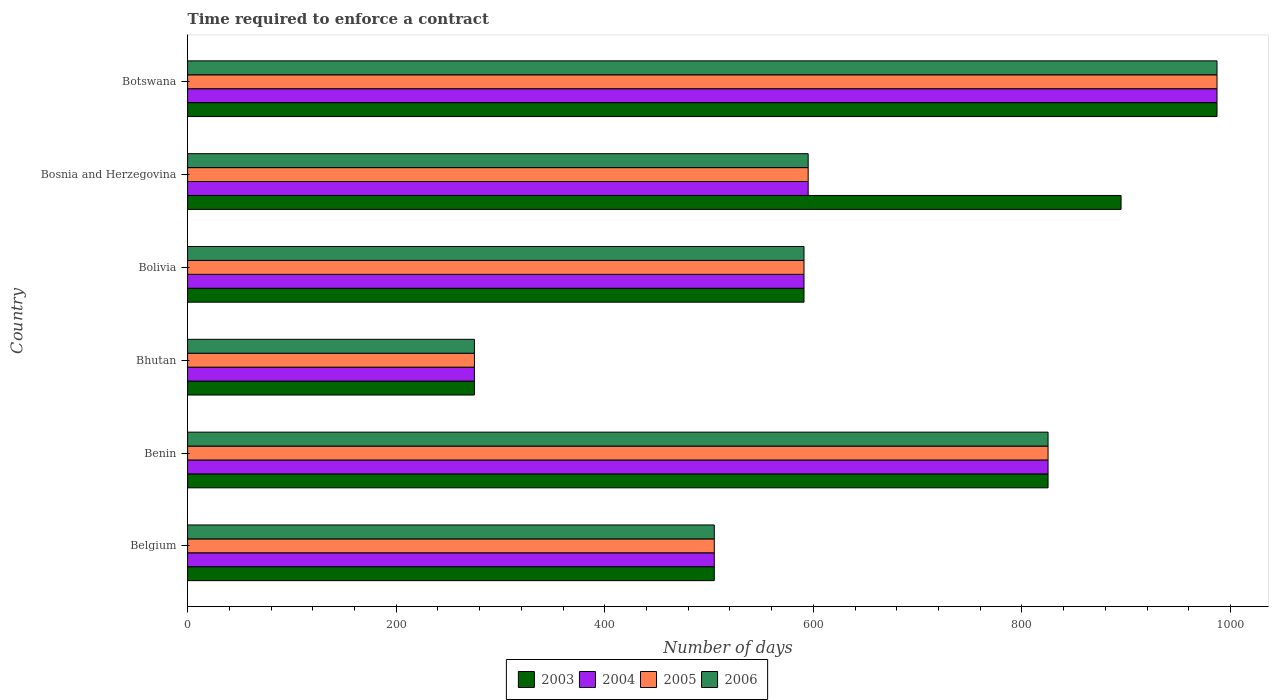How many different coloured bars are there?
Your answer should be compact. 4. Are the number of bars per tick equal to the number of legend labels?
Offer a very short reply. Yes. What is the label of the 3rd group of bars from the top?
Keep it short and to the point. Bolivia. In how many cases, is the number of bars for a given country not equal to the number of legend labels?
Your response must be concise. 0. What is the number of days required to enforce a contract in 2005 in Bosnia and Herzegovina?
Ensure brevity in your answer.  595. Across all countries, what is the maximum number of days required to enforce a contract in 2004?
Offer a very short reply. 987. Across all countries, what is the minimum number of days required to enforce a contract in 2003?
Provide a short and direct response. 275. In which country was the number of days required to enforce a contract in 2006 maximum?
Provide a succinct answer. Botswana. In which country was the number of days required to enforce a contract in 2004 minimum?
Provide a succinct answer. Bhutan. What is the total number of days required to enforce a contract in 2003 in the graph?
Give a very brief answer. 4078. What is the difference between the number of days required to enforce a contract in 2003 in Bhutan and that in Bolivia?
Ensure brevity in your answer.  -316. What is the difference between the number of days required to enforce a contract in 2003 in Benin and the number of days required to enforce a contract in 2005 in Belgium?
Your answer should be very brief. 320. What is the average number of days required to enforce a contract in 2006 per country?
Give a very brief answer. 629.67. What is the ratio of the number of days required to enforce a contract in 2004 in Bolivia to that in Botswana?
Keep it short and to the point. 0.6. Is the number of days required to enforce a contract in 2004 in Bosnia and Herzegovina less than that in Botswana?
Give a very brief answer. Yes. What is the difference between the highest and the second highest number of days required to enforce a contract in 2006?
Offer a terse response. 162. What is the difference between the highest and the lowest number of days required to enforce a contract in 2003?
Your answer should be compact. 712. Is the sum of the number of days required to enforce a contract in 2006 in Bosnia and Herzegovina and Botswana greater than the maximum number of days required to enforce a contract in 2004 across all countries?
Keep it short and to the point. Yes. Is it the case that in every country, the sum of the number of days required to enforce a contract in 2004 and number of days required to enforce a contract in 2005 is greater than the number of days required to enforce a contract in 2006?
Keep it short and to the point. Yes. What is the difference between two consecutive major ticks on the X-axis?
Provide a short and direct response. 200. Does the graph contain any zero values?
Keep it short and to the point. No. What is the title of the graph?
Offer a terse response. Time required to enforce a contract. Does "1989" appear as one of the legend labels in the graph?
Your answer should be very brief. No. What is the label or title of the X-axis?
Give a very brief answer. Number of days. What is the Number of days of 2003 in Belgium?
Your response must be concise. 505. What is the Number of days in 2004 in Belgium?
Your response must be concise. 505. What is the Number of days in 2005 in Belgium?
Provide a succinct answer. 505. What is the Number of days of 2006 in Belgium?
Your response must be concise. 505. What is the Number of days in 2003 in Benin?
Provide a succinct answer. 825. What is the Number of days of 2004 in Benin?
Your answer should be compact. 825. What is the Number of days in 2005 in Benin?
Your answer should be very brief. 825. What is the Number of days in 2006 in Benin?
Your answer should be compact. 825. What is the Number of days in 2003 in Bhutan?
Provide a short and direct response. 275. What is the Number of days in 2004 in Bhutan?
Provide a short and direct response. 275. What is the Number of days in 2005 in Bhutan?
Your answer should be very brief. 275. What is the Number of days of 2006 in Bhutan?
Provide a succinct answer. 275. What is the Number of days of 2003 in Bolivia?
Offer a terse response. 591. What is the Number of days in 2004 in Bolivia?
Give a very brief answer. 591. What is the Number of days of 2005 in Bolivia?
Offer a very short reply. 591. What is the Number of days of 2006 in Bolivia?
Your response must be concise. 591. What is the Number of days of 2003 in Bosnia and Herzegovina?
Offer a very short reply. 895. What is the Number of days in 2004 in Bosnia and Herzegovina?
Ensure brevity in your answer.  595. What is the Number of days of 2005 in Bosnia and Herzegovina?
Your answer should be compact. 595. What is the Number of days in 2006 in Bosnia and Herzegovina?
Provide a short and direct response. 595. What is the Number of days in 2003 in Botswana?
Ensure brevity in your answer.  987. What is the Number of days in 2004 in Botswana?
Give a very brief answer. 987. What is the Number of days in 2005 in Botswana?
Provide a succinct answer. 987. What is the Number of days of 2006 in Botswana?
Your response must be concise. 987. Across all countries, what is the maximum Number of days of 2003?
Ensure brevity in your answer.  987. Across all countries, what is the maximum Number of days in 2004?
Make the answer very short. 987. Across all countries, what is the maximum Number of days of 2005?
Your answer should be compact. 987. Across all countries, what is the maximum Number of days of 2006?
Your response must be concise. 987. Across all countries, what is the minimum Number of days in 2003?
Make the answer very short. 275. Across all countries, what is the minimum Number of days in 2004?
Ensure brevity in your answer.  275. Across all countries, what is the minimum Number of days in 2005?
Ensure brevity in your answer.  275. Across all countries, what is the minimum Number of days in 2006?
Provide a succinct answer. 275. What is the total Number of days in 2003 in the graph?
Keep it short and to the point. 4078. What is the total Number of days in 2004 in the graph?
Provide a succinct answer. 3778. What is the total Number of days in 2005 in the graph?
Your answer should be compact. 3778. What is the total Number of days in 2006 in the graph?
Give a very brief answer. 3778. What is the difference between the Number of days of 2003 in Belgium and that in Benin?
Your answer should be compact. -320. What is the difference between the Number of days of 2004 in Belgium and that in Benin?
Your response must be concise. -320. What is the difference between the Number of days in 2005 in Belgium and that in Benin?
Provide a succinct answer. -320. What is the difference between the Number of days of 2006 in Belgium and that in Benin?
Give a very brief answer. -320. What is the difference between the Number of days in 2003 in Belgium and that in Bhutan?
Your response must be concise. 230. What is the difference between the Number of days in 2004 in Belgium and that in Bhutan?
Offer a terse response. 230. What is the difference between the Number of days of 2005 in Belgium and that in Bhutan?
Offer a terse response. 230. What is the difference between the Number of days of 2006 in Belgium and that in Bhutan?
Keep it short and to the point. 230. What is the difference between the Number of days in 2003 in Belgium and that in Bolivia?
Provide a succinct answer. -86. What is the difference between the Number of days in 2004 in Belgium and that in Bolivia?
Give a very brief answer. -86. What is the difference between the Number of days of 2005 in Belgium and that in Bolivia?
Your answer should be compact. -86. What is the difference between the Number of days of 2006 in Belgium and that in Bolivia?
Keep it short and to the point. -86. What is the difference between the Number of days in 2003 in Belgium and that in Bosnia and Herzegovina?
Ensure brevity in your answer.  -390. What is the difference between the Number of days in 2004 in Belgium and that in Bosnia and Herzegovina?
Your answer should be very brief. -90. What is the difference between the Number of days in 2005 in Belgium and that in Bosnia and Herzegovina?
Ensure brevity in your answer.  -90. What is the difference between the Number of days in 2006 in Belgium and that in Bosnia and Herzegovina?
Provide a succinct answer. -90. What is the difference between the Number of days in 2003 in Belgium and that in Botswana?
Your answer should be compact. -482. What is the difference between the Number of days in 2004 in Belgium and that in Botswana?
Make the answer very short. -482. What is the difference between the Number of days of 2005 in Belgium and that in Botswana?
Offer a very short reply. -482. What is the difference between the Number of days in 2006 in Belgium and that in Botswana?
Ensure brevity in your answer.  -482. What is the difference between the Number of days of 2003 in Benin and that in Bhutan?
Your response must be concise. 550. What is the difference between the Number of days in 2004 in Benin and that in Bhutan?
Offer a terse response. 550. What is the difference between the Number of days in 2005 in Benin and that in Bhutan?
Your answer should be very brief. 550. What is the difference between the Number of days in 2006 in Benin and that in Bhutan?
Your answer should be compact. 550. What is the difference between the Number of days of 2003 in Benin and that in Bolivia?
Provide a short and direct response. 234. What is the difference between the Number of days of 2004 in Benin and that in Bolivia?
Your response must be concise. 234. What is the difference between the Number of days of 2005 in Benin and that in Bolivia?
Ensure brevity in your answer.  234. What is the difference between the Number of days in 2006 in Benin and that in Bolivia?
Your answer should be very brief. 234. What is the difference between the Number of days in 2003 in Benin and that in Bosnia and Herzegovina?
Provide a succinct answer. -70. What is the difference between the Number of days of 2004 in Benin and that in Bosnia and Herzegovina?
Your answer should be very brief. 230. What is the difference between the Number of days in 2005 in Benin and that in Bosnia and Herzegovina?
Make the answer very short. 230. What is the difference between the Number of days in 2006 in Benin and that in Bosnia and Herzegovina?
Keep it short and to the point. 230. What is the difference between the Number of days in 2003 in Benin and that in Botswana?
Your answer should be compact. -162. What is the difference between the Number of days of 2004 in Benin and that in Botswana?
Offer a terse response. -162. What is the difference between the Number of days of 2005 in Benin and that in Botswana?
Your answer should be very brief. -162. What is the difference between the Number of days in 2006 in Benin and that in Botswana?
Your response must be concise. -162. What is the difference between the Number of days in 2003 in Bhutan and that in Bolivia?
Ensure brevity in your answer.  -316. What is the difference between the Number of days in 2004 in Bhutan and that in Bolivia?
Your answer should be very brief. -316. What is the difference between the Number of days of 2005 in Bhutan and that in Bolivia?
Keep it short and to the point. -316. What is the difference between the Number of days in 2006 in Bhutan and that in Bolivia?
Offer a terse response. -316. What is the difference between the Number of days of 2003 in Bhutan and that in Bosnia and Herzegovina?
Offer a very short reply. -620. What is the difference between the Number of days of 2004 in Bhutan and that in Bosnia and Herzegovina?
Provide a short and direct response. -320. What is the difference between the Number of days in 2005 in Bhutan and that in Bosnia and Herzegovina?
Keep it short and to the point. -320. What is the difference between the Number of days of 2006 in Bhutan and that in Bosnia and Herzegovina?
Give a very brief answer. -320. What is the difference between the Number of days in 2003 in Bhutan and that in Botswana?
Your answer should be compact. -712. What is the difference between the Number of days in 2004 in Bhutan and that in Botswana?
Offer a terse response. -712. What is the difference between the Number of days in 2005 in Bhutan and that in Botswana?
Make the answer very short. -712. What is the difference between the Number of days in 2006 in Bhutan and that in Botswana?
Your response must be concise. -712. What is the difference between the Number of days in 2003 in Bolivia and that in Bosnia and Herzegovina?
Offer a terse response. -304. What is the difference between the Number of days in 2005 in Bolivia and that in Bosnia and Herzegovina?
Ensure brevity in your answer.  -4. What is the difference between the Number of days of 2003 in Bolivia and that in Botswana?
Ensure brevity in your answer.  -396. What is the difference between the Number of days in 2004 in Bolivia and that in Botswana?
Your answer should be compact. -396. What is the difference between the Number of days in 2005 in Bolivia and that in Botswana?
Your answer should be very brief. -396. What is the difference between the Number of days of 2006 in Bolivia and that in Botswana?
Make the answer very short. -396. What is the difference between the Number of days in 2003 in Bosnia and Herzegovina and that in Botswana?
Keep it short and to the point. -92. What is the difference between the Number of days in 2004 in Bosnia and Herzegovina and that in Botswana?
Provide a short and direct response. -392. What is the difference between the Number of days of 2005 in Bosnia and Herzegovina and that in Botswana?
Ensure brevity in your answer.  -392. What is the difference between the Number of days in 2006 in Bosnia and Herzegovina and that in Botswana?
Make the answer very short. -392. What is the difference between the Number of days of 2003 in Belgium and the Number of days of 2004 in Benin?
Provide a short and direct response. -320. What is the difference between the Number of days of 2003 in Belgium and the Number of days of 2005 in Benin?
Keep it short and to the point. -320. What is the difference between the Number of days in 2003 in Belgium and the Number of days in 2006 in Benin?
Offer a very short reply. -320. What is the difference between the Number of days in 2004 in Belgium and the Number of days in 2005 in Benin?
Keep it short and to the point. -320. What is the difference between the Number of days in 2004 in Belgium and the Number of days in 2006 in Benin?
Ensure brevity in your answer.  -320. What is the difference between the Number of days in 2005 in Belgium and the Number of days in 2006 in Benin?
Offer a terse response. -320. What is the difference between the Number of days of 2003 in Belgium and the Number of days of 2004 in Bhutan?
Provide a succinct answer. 230. What is the difference between the Number of days of 2003 in Belgium and the Number of days of 2005 in Bhutan?
Keep it short and to the point. 230. What is the difference between the Number of days of 2003 in Belgium and the Number of days of 2006 in Bhutan?
Give a very brief answer. 230. What is the difference between the Number of days in 2004 in Belgium and the Number of days in 2005 in Bhutan?
Make the answer very short. 230. What is the difference between the Number of days of 2004 in Belgium and the Number of days of 2006 in Bhutan?
Provide a succinct answer. 230. What is the difference between the Number of days in 2005 in Belgium and the Number of days in 2006 in Bhutan?
Your answer should be compact. 230. What is the difference between the Number of days of 2003 in Belgium and the Number of days of 2004 in Bolivia?
Provide a succinct answer. -86. What is the difference between the Number of days of 2003 in Belgium and the Number of days of 2005 in Bolivia?
Your answer should be very brief. -86. What is the difference between the Number of days of 2003 in Belgium and the Number of days of 2006 in Bolivia?
Ensure brevity in your answer.  -86. What is the difference between the Number of days in 2004 in Belgium and the Number of days in 2005 in Bolivia?
Your answer should be very brief. -86. What is the difference between the Number of days in 2004 in Belgium and the Number of days in 2006 in Bolivia?
Your response must be concise. -86. What is the difference between the Number of days of 2005 in Belgium and the Number of days of 2006 in Bolivia?
Provide a succinct answer. -86. What is the difference between the Number of days of 2003 in Belgium and the Number of days of 2004 in Bosnia and Herzegovina?
Keep it short and to the point. -90. What is the difference between the Number of days of 2003 in Belgium and the Number of days of 2005 in Bosnia and Herzegovina?
Offer a very short reply. -90. What is the difference between the Number of days of 2003 in Belgium and the Number of days of 2006 in Bosnia and Herzegovina?
Provide a short and direct response. -90. What is the difference between the Number of days of 2004 in Belgium and the Number of days of 2005 in Bosnia and Herzegovina?
Your response must be concise. -90. What is the difference between the Number of days of 2004 in Belgium and the Number of days of 2006 in Bosnia and Herzegovina?
Offer a terse response. -90. What is the difference between the Number of days in 2005 in Belgium and the Number of days in 2006 in Bosnia and Herzegovina?
Your answer should be very brief. -90. What is the difference between the Number of days of 2003 in Belgium and the Number of days of 2004 in Botswana?
Provide a short and direct response. -482. What is the difference between the Number of days of 2003 in Belgium and the Number of days of 2005 in Botswana?
Provide a succinct answer. -482. What is the difference between the Number of days of 2003 in Belgium and the Number of days of 2006 in Botswana?
Give a very brief answer. -482. What is the difference between the Number of days of 2004 in Belgium and the Number of days of 2005 in Botswana?
Your answer should be compact. -482. What is the difference between the Number of days in 2004 in Belgium and the Number of days in 2006 in Botswana?
Provide a succinct answer. -482. What is the difference between the Number of days of 2005 in Belgium and the Number of days of 2006 in Botswana?
Keep it short and to the point. -482. What is the difference between the Number of days in 2003 in Benin and the Number of days in 2004 in Bhutan?
Offer a terse response. 550. What is the difference between the Number of days in 2003 in Benin and the Number of days in 2005 in Bhutan?
Provide a succinct answer. 550. What is the difference between the Number of days of 2003 in Benin and the Number of days of 2006 in Bhutan?
Give a very brief answer. 550. What is the difference between the Number of days in 2004 in Benin and the Number of days in 2005 in Bhutan?
Give a very brief answer. 550. What is the difference between the Number of days of 2004 in Benin and the Number of days of 2006 in Bhutan?
Provide a short and direct response. 550. What is the difference between the Number of days of 2005 in Benin and the Number of days of 2006 in Bhutan?
Provide a succinct answer. 550. What is the difference between the Number of days in 2003 in Benin and the Number of days in 2004 in Bolivia?
Offer a terse response. 234. What is the difference between the Number of days of 2003 in Benin and the Number of days of 2005 in Bolivia?
Your response must be concise. 234. What is the difference between the Number of days of 2003 in Benin and the Number of days of 2006 in Bolivia?
Offer a terse response. 234. What is the difference between the Number of days in 2004 in Benin and the Number of days in 2005 in Bolivia?
Your response must be concise. 234. What is the difference between the Number of days of 2004 in Benin and the Number of days of 2006 in Bolivia?
Offer a terse response. 234. What is the difference between the Number of days of 2005 in Benin and the Number of days of 2006 in Bolivia?
Give a very brief answer. 234. What is the difference between the Number of days in 2003 in Benin and the Number of days in 2004 in Bosnia and Herzegovina?
Keep it short and to the point. 230. What is the difference between the Number of days in 2003 in Benin and the Number of days in 2005 in Bosnia and Herzegovina?
Your answer should be very brief. 230. What is the difference between the Number of days of 2003 in Benin and the Number of days of 2006 in Bosnia and Herzegovina?
Provide a short and direct response. 230. What is the difference between the Number of days of 2004 in Benin and the Number of days of 2005 in Bosnia and Herzegovina?
Your response must be concise. 230. What is the difference between the Number of days of 2004 in Benin and the Number of days of 2006 in Bosnia and Herzegovina?
Offer a terse response. 230. What is the difference between the Number of days of 2005 in Benin and the Number of days of 2006 in Bosnia and Herzegovina?
Keep it short and to the point. 230. What is the difference between the Number of days in 2003 in Benin and the Number of days in 2004 in Botswana?
Provide a succinct answer. -162. What is the difference between the Number of days in 2003 in Benin and the Number of days in 2005 in Botswana?
Offer a terse response. -162. What is the difference between the Number of days in 2003 in Benin and the Number of days in 2006 in Botswana?
Keep it short and to the point. -162. What is the difference between the Number of days in 2004 in Benin and the Number of days in 2005 in Botswana?
Offer a terse response. -162. What is the difference between the Number of days in 2004 in Benin and the Number of days in 2006 in Botswana?
Provide a short and direct response. -162. What is the difference between the Number of days in 2005 in Benin and the Number of days in 2006 in Botswana?
Give a very brief answer. -162. What is the difference between the Number of days of 2003 in Bhutan and the Number of days of 2004 in Bolivia?
Your answer should be compact. -316. What is the difference between the Number of days of 2003 in Bhutan and the Number of days of 2005 in Bolivia?
Your answer should be very brief. -316. What is the difference between the Number of days in 2003 in Bhutan and the Number of days in 2006 in Bolivia?
Keep it short and to the point. -316. What is the difference between the Number of days in 2004 in Bhutan and the Number of days in 2005 in Bolivia?
Offer a very short reply. -316. What is the difference between the Number of days in 2004 in Bhutan and the Number of days in 2006 in Bolivia?
Your response must be concise. -316. What is the difference between the Number of days of 2005 in Bhutan and the Number of days of 2006 in Bolivia?
Your response must be concise. -316. What is the difference between the Number of days of 2003 in Bhutan and the Number of days of 2004 in Bosnia and Herzegovina?
Keep it short and to the point. -320. What is the difference between the Number of days in 2003 in Bhutan and the Number of days in 2005 in Bosnia and Herzegovina?
Offer a terse response. -320. What is the difference between the Number of days of 2003 in Bhutan and the Number of days of 2006 in Bosnia and Herzegovina?
Your answer should be compact. -320. What is the difference between the Number of days in 2004 in Bhutan and the Number of days in 2005 in Bosnia and Herzegovina?
Provide a succinct answer. -320. What is the difference between the Number of days in 2004 in Bhutan and the Number of days in 2006 in Bosnia and Herzegovina?
Give a very brief answer. -320. What is the difference between the Number of days in 2005 in Bhutan and the Number of days in 2006 in Bosnia and Herzegovina?
Provide a short and direct response. -320. What is the difference between the Number of days in 2003 in Bhutan and the Number of days in 2004 in Botswana?
Your answer should be very brief. -712. What is the difference between the Number of days in 2003 in Bhutan and the Number of days in 2005 in Botswana?
Ensure brevity in your answer.  -712. What is the difference between the Number of days of 2003 in Bhutan and the Number of days of 2006 in Botswana?
Your response must be concise. -712. What is the difference between the Number of days in 2004 in Bhutan and the Number of days in 2005 in Botswana?
Make the answer very short. -712. What is the difference between the Number of days in 2004 in Bhutan and the Number of days in 2006 in Botswana?
Keep it short and to the point. -712. What is the difference between the Number of days of 2005 in Bhutan and the Number of days of 2006 in Botswana?
Your answer should be very brief. -712. What is the difference between the Number of days in 2003 in Bolivia and the Number of days in 2006 in Bosnia and Herzegovina?
Your answer should be very brief. -4. What is the difference between the Number of days of 2004 in Bolivia and the Number of days of 2006 in Bosnia and Herzegovina?
Ensure brevity in your answer.  -4. What is the difference between the Number of days of 2005 in Bolivia and the Number of days of 2006 in Bosnia and Herzegovina?
Your response must be concise. -4. What is the difference between the Number of days in 2003 in Bolivia and the Number of days in 2004 in Botswana?
Offer a very short reply. -396. What is the difference between the Number of days in 2003 in Bolivia and the Number of days in 2005 in Botswana?
Ensure brevity in your answer.  -396. What is the difference between the Number of days in 2003 in Bolivia and the Number of days in 2006 in Botswana?
Give a very brief answer. -396. What is the difference between the Number of days of 2004 in Bolivia and the Number of days of 2005 in Botswana?
Provide a short and direct response. -396. What is the difference between the Number of days in 2004 in Bolivia and the Number of days in 2006 in Botswana?
Ensure brevity in your answer.  -396. What is the difference between the Number of days in 2005 in Bolivia and the Number of days in 2006 in Botswana?
Keep it short and to the point. -396. What is the difference between the Number of days in 2003 in Bosnia and Herzegovina and the Number of days in 2004 in Botswana?
Provide a succinct answer. -92. What is the difference between the Number of days of 2003 in Bosnia and Herzegovina and the Number of days of 2005 in Botswana?
Keep it short and to the point. -92. What is the difference between the Number of days of 2003 in Bosnia and Herzegovina and the Number of days of 2006 in Botswana?
Give a very brief answer. -92. What is the difference between the Number of days in 2004 in Bosnia and Herzegovina and the Number of days in 2005 in Botswana?
Your response must be concise. -392. What is the difference between the Number of days in 2004 in Bosnia and Herzegovina and the Number of days in 2006 in Botswana?
Your answer should be compact. -392. What is the difference between the Number of days of 2005 in Bosnia and Herzegovina and the Number of days of 2006 in Botswana?
Give a very brief answer. -392. What is the average Number of days in 2003 per country?
Provide a succinct answer. 679.67. What is the average Number of days in 2004 per country?
Provide a short and direct response. 629.67. What is the average Number of days in 2005 per country?
Ensure brevity in your answer.  629.67. What is the average Number of days in 2006 per country?
Provide a succinct answer. 629.67. What is the difference between the Number of days in 2003 and Number of days in 2004 in Belgium?
Provide a short and direct response. 0. What is the difference between the Number of days in 2003 and Number of days in 2005 in Belgium?
Your response must be concise. 0. What is the difference between the Number of days of 2003 and Number of days of 2005 in Benin?
Your answer should be very brief. 0. What is the difference between the Number of days in 2003 and Number of days in 2006 in Benin?
Keep it short and to the point. 0. What is the difference between the Number of days in 2004 and Number of days in 2005 in Benin?
Offer a terse response. 0. What is the difference between the Number of days in 2004 and Number of days in 2006 in Benin?
Your response must be concise. 0. What is the difference between the Number of days of 2005 and Number of days of 2006 in Benin?
Your answer should be compact. 0. What is the difference between the Number of days of 2003 and Number of days of 2006 in Bhutan?
Keep it short and to the point. 0. What is the difference between the Number of days in 2004 and Number of days in 2005 in Bhutan?
Offer a very short reply. 0. What is the difference between the Number of days of 2005 and Number of days of 2006 in Bhutan?
Your answer should be very brief. 0. What is the difference between the Number of days in 2003 and Number of days in 2004 in Bolivia?
Ensure brevity in your answer.  0. What is the difference between the Number of days in 2003 and Number of days in 2005 in Bolivia?
Your response must be concise. 0. What is the difference between the Number of days in 2004 and Number of days in 2006 in Bolivia?
Make the answer very short. 0. What is the difference between the Number of days in 2005 and Number of days in 2006 in Bolivia?
Ensure brevity in your answer.  0. What is the difference between the Number of days of 2003 and Number of days of 2004 in Bosnia and Herzegovina?
Make the answer very short. 300. What is the difference between the Number of days of 2003 and Number of days of 2005 in Bosnia and Herzegovina?
Your answer should be very brief. 300. What is the difference between the Number of days of 2003 and Number of days of 2006 in Bosnia and Herzegovina?
Your response must be concise. 300. What is the difference between the Number of days in 2004 and Number of days in 2005 in Bosnia and Herzegovina?
Ensure brevity in your answer.  0. What is the difference between the Number of days in 2004 and Number of days in 2006 in Bosnia and Herzegovina?
Keep it short and to the point. 0. What is the difference between the Number of days of 2003 and Number of days of 2006 in Botswana?
Give a very brief answer. 0. What is the difference between the Number of days in 2004 and Number of days in 2005 in Botswana?
Your answer should be compact. 0. What is the difference between the Number of days of 2005 and Number of days of 2006 in Botswana?
Provide a succinct answer. 0. What is the ratio of the Number of days in 2003 in Belgium to that in Benin?
Offer a terse response. 0.61. What is the ratio of the Number of days of 2004 in Belgium to that in Benin?
Give a very brief answer. 0.61. What is the ratio of the Number of days in 2005 in Belgium to that in Benin?
Your answer should be very brief. 0.61. What is the ratio of the Number of days in 2006 in Belgium to that in Benin?
Make the answer very short. 0.61. What is the ratio of the Number of days of 2003 in Belgium to that in Bhutan?
Your response must be concise. 1.84. What is the ratio of the Number of days in 2004 in Belgium to that in Bhutan?
Provide a short and direct response. 1.84. What is the ratio of the Number of days of 2005 in Belgium to that in Bhutan?
Provide a succinct answer. 1.84. What is the ratio of the Number of days of 2006 in Belgium to that in Bhutan?
Your answer should be compact. 1.84. What is the ratio of the Number of days of 2003 in Belgium to that in Bolivia?
Keep it short and to the point. 0.85. What is the ratio of the Number of days in 2004 in Belgium to that in Bolivia?
Ensure brevity in your answer.  0.85. What is the ratio of the Number of days in 2005 in Belgium to that in Bolivia?
Make the answer very short. 0.85. What is the ratio of the Number of days in 2006 in Belgium to that in Bolivia?
Ensure brevity in your answer.  0.85. What is the ratio of the Number of days in 2003 in Belgium to that in Bosnia and Herzegovina?
Keep it short and to the point. 0.56. What is the ratio of the Number of days in 2004 in Belgium to that in Bosnia and Herzegovina?
Offer a terse response. 0.85. What is the ratio of the Number of days in 2005 in Belgium to that in Bosnia and Herzegovina?
Provide a short and direct response. 0.85. What is the ratio of the Number of days in 2006 in Belgium to that in Bosnia and Herzegovina?
Provide a succinct answer. 0.85. What is the ratio of the Number of days in 2003 in Belgium to that in Botswana?
Offer a very short reply. 0.51. What is the ratio of the Number of days of 2004 in Belgium to that in Botswana?
Provide a short and direct response. 0.51. What is the ratio of the Number of days of 2005 in Belgium to that in Botswana?
Keep it short and to the point. 0.51. What is the ratio of the Number of days of 2006 in Belgium to that in Botswana?
Your response must be concise. 0.51. What is the ratio of the Number of days of 2003 in Benin to that in Bhutan?
Your response must be concise. 3. What is the ratio of the Number of days of 2006 in Benin to that in Bhutan?
Give a very brief answer. 3. What is the ratio of the Number of days of 2003 in Benin to that in Bolivia?
Keep it short and to the point. 1.4. What is the ratio of the Number of days of 2004 in Benin to that in Bolivia?
Your answer should be very brief. 1.4. What is the ratio of the Number of days in 2005 in Benin to that in Bolivia?
Give a very brief answer. 1.4. What is the ratio of the Number of days in 2006 in Benin to that in Bolivia?
Provide a short and direct response. 1.4. What is the ratio of the Number of days in 2003 in Benin to that in Bosnia and Herzegovina?
Ensure brevity in your answer.  0.92. What is the ratio of the Number of days of 2004 in Benin to that in Bosnia and Herzegovina?
Ensure brevity in your answer.  1.39. What is the ratio of the Number of days of 2005 in Benin to that in Bosnia and Herzegovina?
Ensure brevity in your answer.  1.39. What is the ratio of the Number of days of 2006 in Benin to that in Bosnia and Herzegovina?
Your answer should be very brief. 1.39. What is the ratio of the Number of days in 2003 in Benin to that in Botswana?
Make the answer very short. 0.84. What is the ratio of the Number of days of 2004 in Benin to that in Botswana?
Offer a very short reply. 0.84. What is the ratio of the Number of days of 2005 in Benin to that in Botswana?
Provide a short and direct response. 0.84. What is the ratio of the Number of days in 2006 in Benin to that in Botswana?
Your answer should be very brief. 0.84. What is the ratio of the Number of days in 2003 in Bhutan to that in Bolivia?
Offer a very short reply. 0.47. What is the ratio of the Number of days of 2004 in Bhutan to that in Bolivia?
Provide a succinct answer. 0.47. What is the ratio of the Number of days in 2005 in Bhutan to that in Bolivia?
Keep it short and to the point. 0.47. What is the ratio of the Number of days in 2006 in Bhutan to that in Bolivia?
Offer a terse response. 0.47. What is the ratio of the Number of days in 2003 in Bhutan to that in Bosnia and Herzegovina?
Make the answer very short. 0.31. What is the ratio of the Number of days in 2004 in Bhutan to that in Bosnia and Herzegovina?
Your answer should be compact. 0.46. What is the ratio of the Number of days of 2005 in Bhutan to that in Bosnia and Herzegovina?
Give a very brief answer. 0.46. What is the ratio of the Number of days in 2006 in Bhutan to that in Bosnia and Herzegovina?
Your response must be concise. 0.46. What is the ratio of the Number of days in 2003 in Bhutan to that in Botswana?
Provide a succinct answer. 0.28. What is the ratio of the Number of days in 2004 in Bhutan to that in Botswana?
Your answer should be very brief. 0.28. What is the ratio of the Number of days in 2005 in Bhutan to that in Botswana?
Your answer should be very brief. 0.28. What is the ratio of the Number of days of 2006 in Bhutan to that in Botswana?
Offer a terse response. 0.28. What is the ratio of the Number of days in 2003 in Bolivia to that in Bosnia and Herzegovina?
Your answer should be compact. 0.66. What is the ratio of the Number of days in 2004 in Bolivia to that in Bosnia and Herzegovina?
Offer a very short reply. 0.99. What is the ratio of the Number of days in 2005 in Bolivia to that in Bosnia and Herzegovina?
Keep it short and to the point. 0.99. What is the ratio of the Number of days in 2006 in Bolivia to that in Bosnia and Herzegovina?
Make the answer very short. 0.99. What is the ratio of the Number of days in 2003 in Bolivia to that in Botswana?
Ensure brevity in your answer.  0.6. What is the ratio of the Number of days in 2004 in Bolivia to that in Botswana?
Keep it short and to the point. 0.6. What is the ratio of the Number of days of 2005 in Bolivia to that in Botswana?
Offer a very short reply. 0.6. What is the ratio of the Number of days in 2006 in Bolivia to that in Botswana?
Give a very brief answer. 0.6. What is the ratio of the Number of days in 2003 in Bosnia and Herzegovina to that in Botswana?
Your response must be concise. 0.91. What is the ratio of the Number of days of 2004 in Bosnia and Herzegovina to that in Botswana?
Your response must be concise. 0.6. What is the ratio of the Number of days in 2005 in Bosnia and Herzegovina to that in Botswana?
Give a very brief answer. 0.6. What is the ratio of the Number of days of 2006 in Bosnia and Herzegovina to that in Botswana?
Provide a short and direct response. 0.6. What is the difference between the highest and the second highest Number of days of 2003?
Your answer should be compact. 92. What is the difference between the highest and the second highest Number of days in 2004?
Your answer should be compact. 162. What is the difference between the highest and the second highest Number of days of 2005?
Offer a very short reply. 162. What is the difference between the highest and the second highest Number of days of 2006?
Give a very brief answer. 162. What is the difference between the highest and the lowest Number of days in 2003?
Offer a terse response. 712. What is the difference between the highest and the lowest Number of days of 2004?
Your response must be concise. 712. What is the difference between the highest and the lowest Number of days of 2005?
Offer a terse response. 712. What is the difference between the highest and the lowest Number of days of 2006?
Your answer should be very brief. 712. 